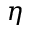<formula> <loc_0><loc_0><loc_500><loc_500>\eta</formula> 